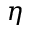<formula> <loc_0><loc_0><loc_500><loc_500>\eta</formula> 